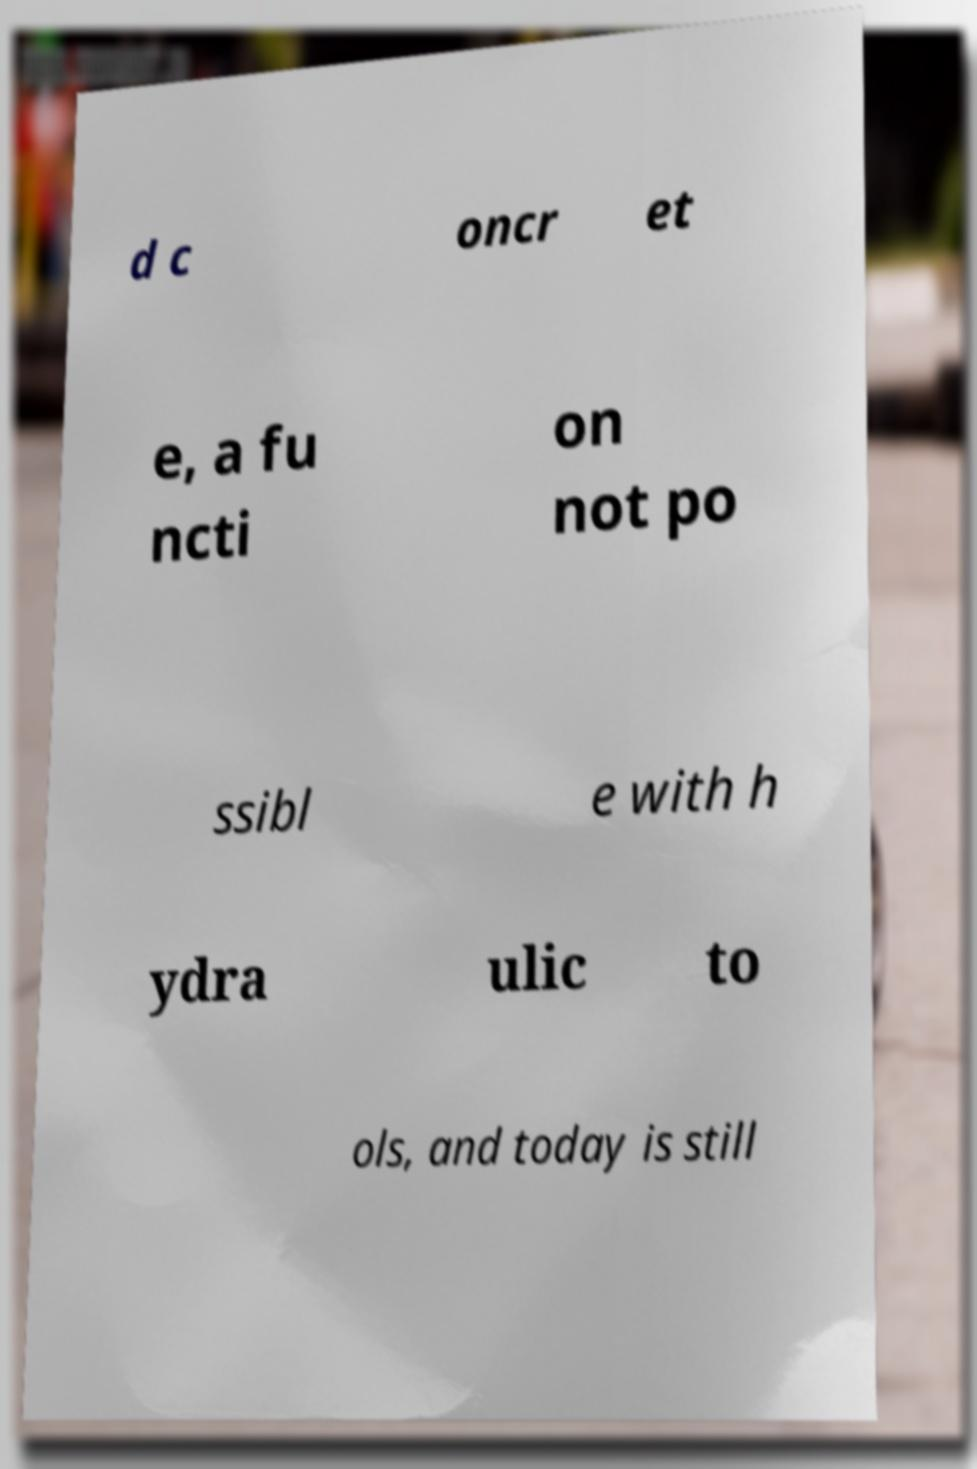Could you assist in decoding the text presented in this image and type it out clearly? d c oncr et e, a fu ncti on not po ssibl e with h ydra ulic to ols, and today is still 